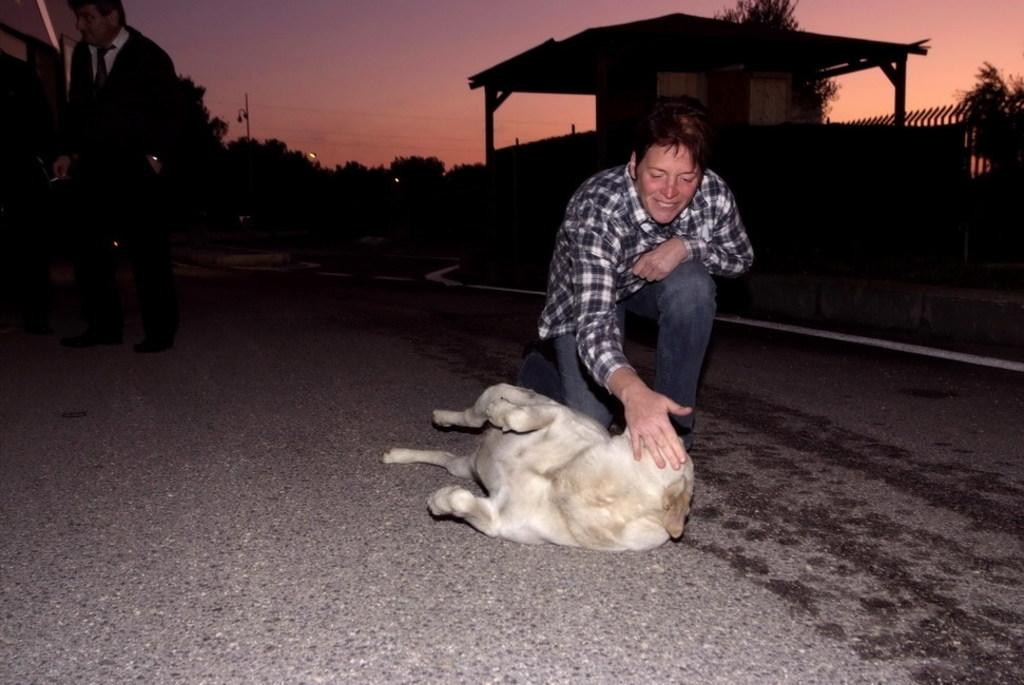What type of vegetation can be seen in the image? There are trees in the image. What part of the natural environment is visible in the image? The sky is visible in the image. What architectural feature can be seen in the image? There is a fence in the image. How many people are present in the image? Two people are standing on the road in the image. What type of animal is present in the image? There is a white-colored dog in the image. What type of cake is being served in the image? There is no cake present in the image. What is the dog writing on the fence in the image? Dogs do not have the ability to write, and there is no writing present in the image. 